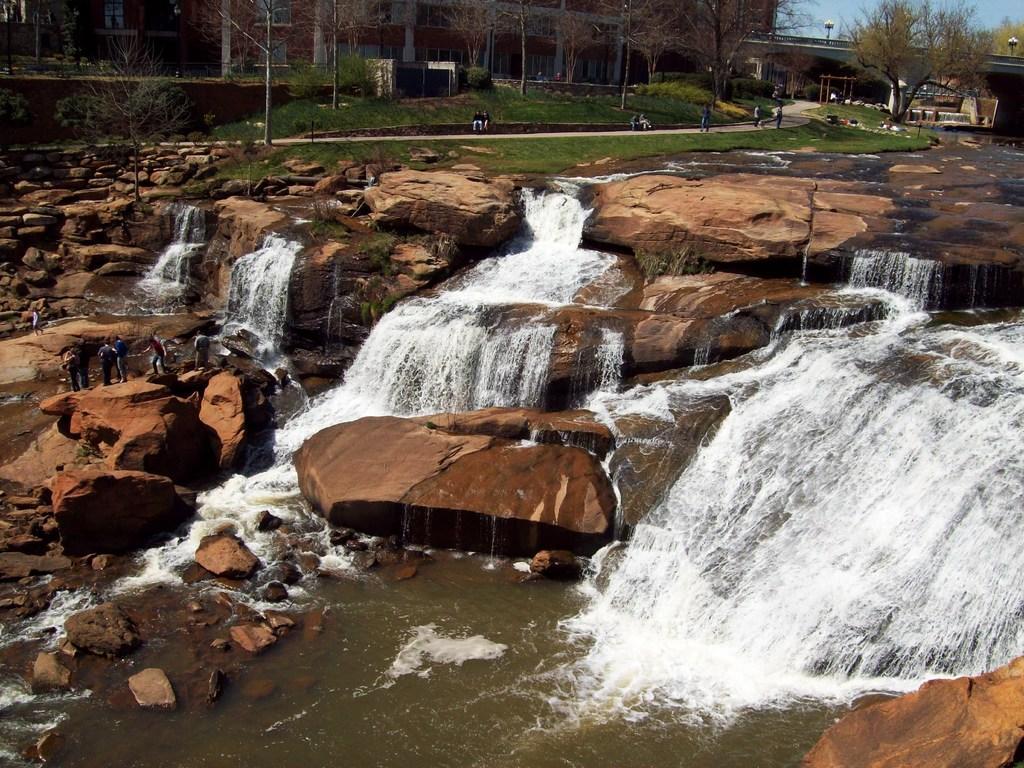Can you describe this image briefly? In this image we can see water flowing on stones. In the background of the image there are buildings, trees, grass, people. 